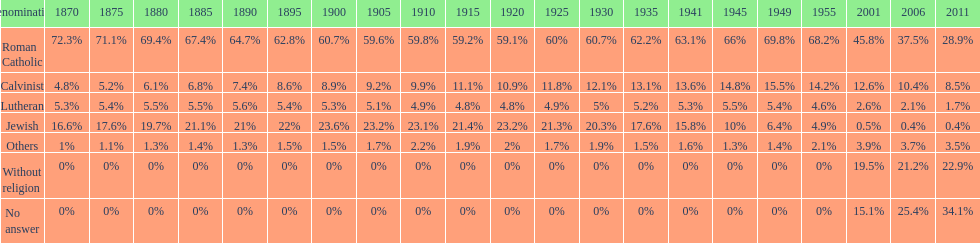Which religious group has the largest margin? Roman Catholic. 